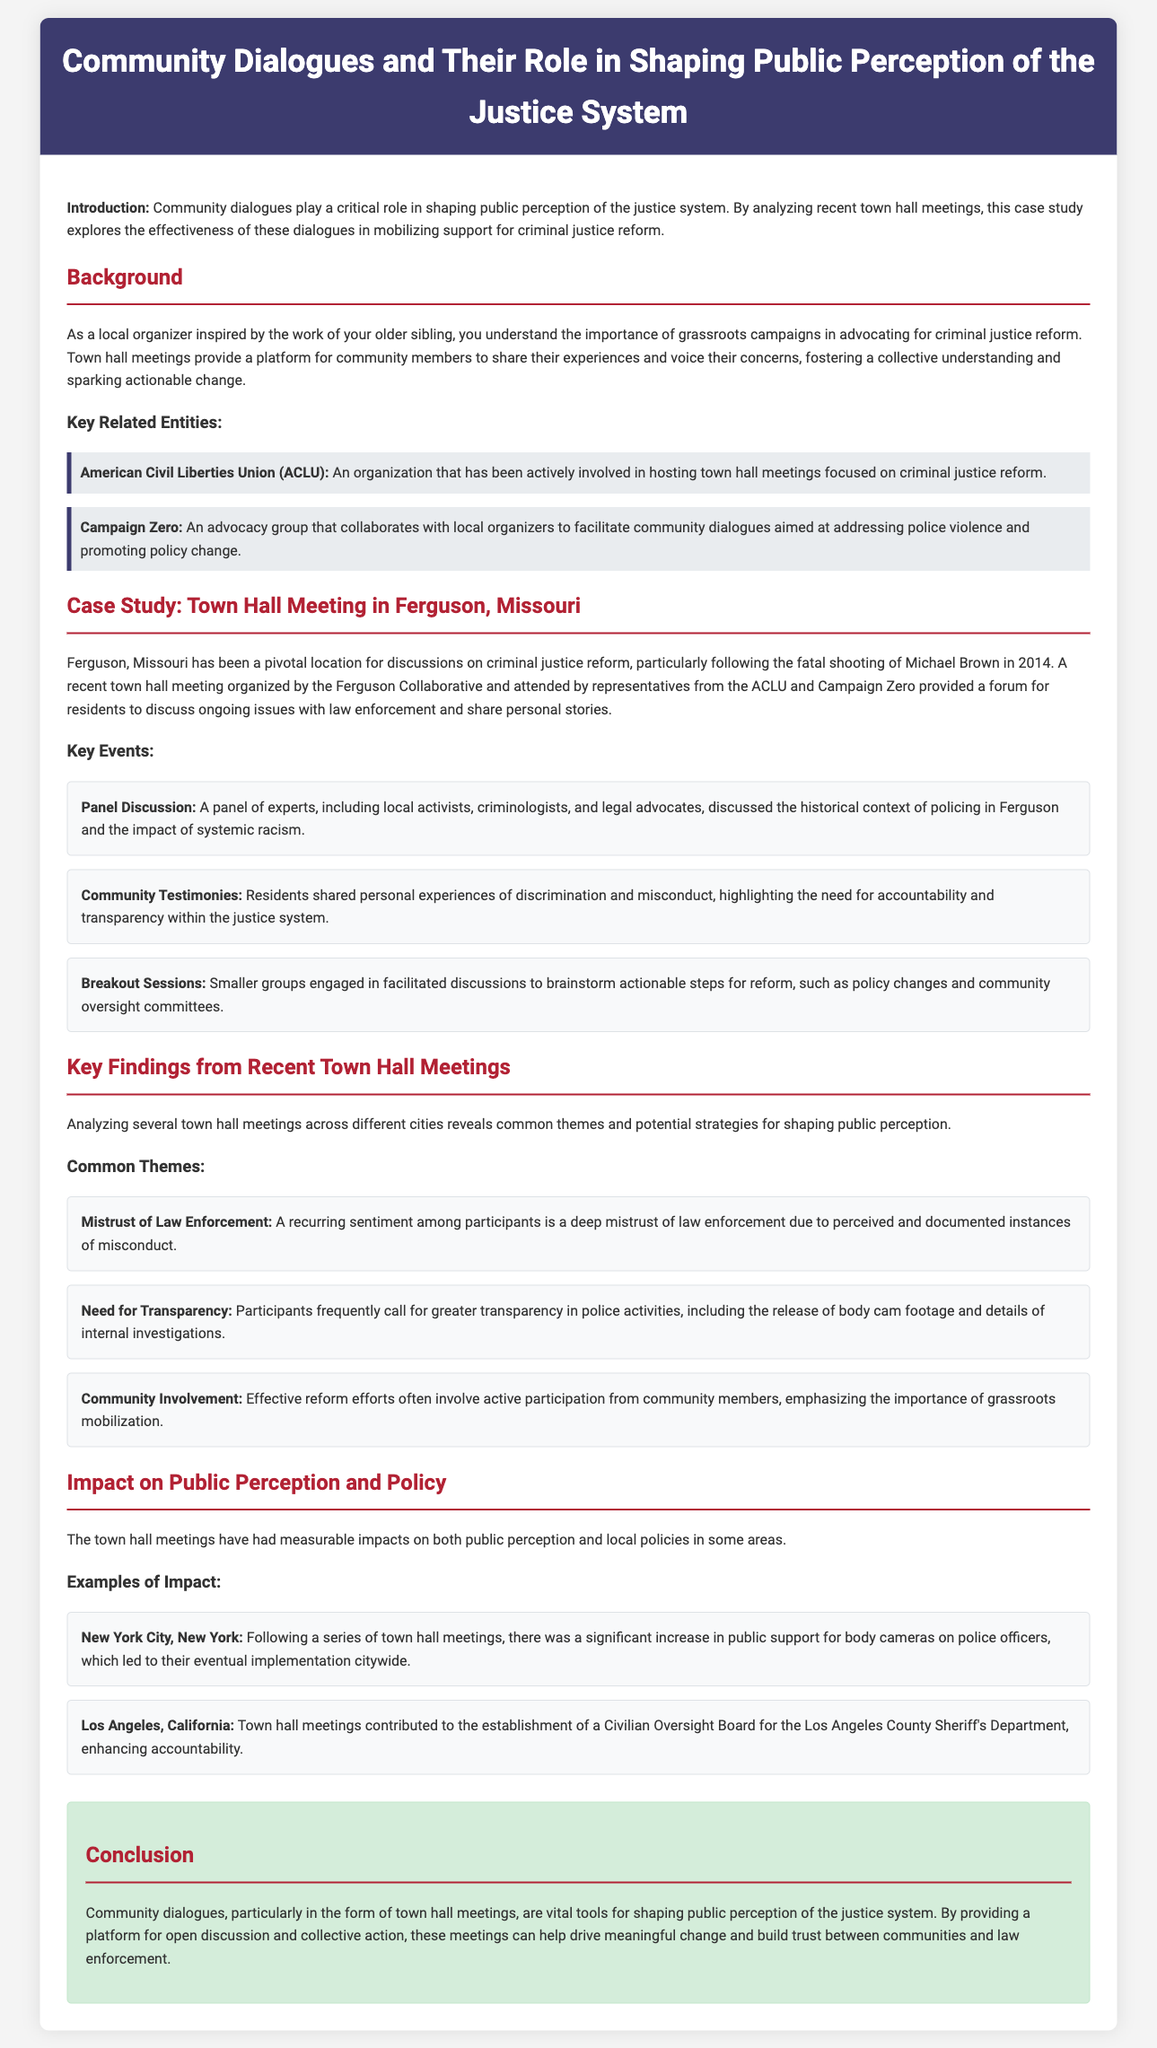What is the role of community dialogues? Community dialogues play a critical role in shaping public perception of the justice system.
Answer: Shaping public perception Who organized the town hall meeting in Ferguson? The Ferguson Collaborative organized the town hall meeting.
Answer: Ferguson Collaborative Which advocacy group collaborates with local organizers on community dialogues? Campaign Zero collaborates with local organizers.
Answer: Campaign Zero What theme emphasizes the need for police accountability? A deep mistrust of law enforcement emphasizes the need for police accountability.
Answer: Mistrust of Law Enforcement What actionable steps were discussed during the breakout sessions? Smaller groups engaged in discussions to brainstorm actionable steps for reform.
Answer: Actionable steps for reform What was one outcome in New York City after town hall meetings? Following a series of town hall meetings, public support for body cameras increased.
Answer: Increased public support for body cameras What two organizations were represented at the Ferguson town hall meeting? The ACLU and Campaign Zero were represented.
Answer: ACLU and Campaign Zero What change did town hall meetings contribute to in Los Angeles? Town hall meetings contributed to the establishment of a Civilian Oversight Board.
Answer: Civilian Oversight Board 